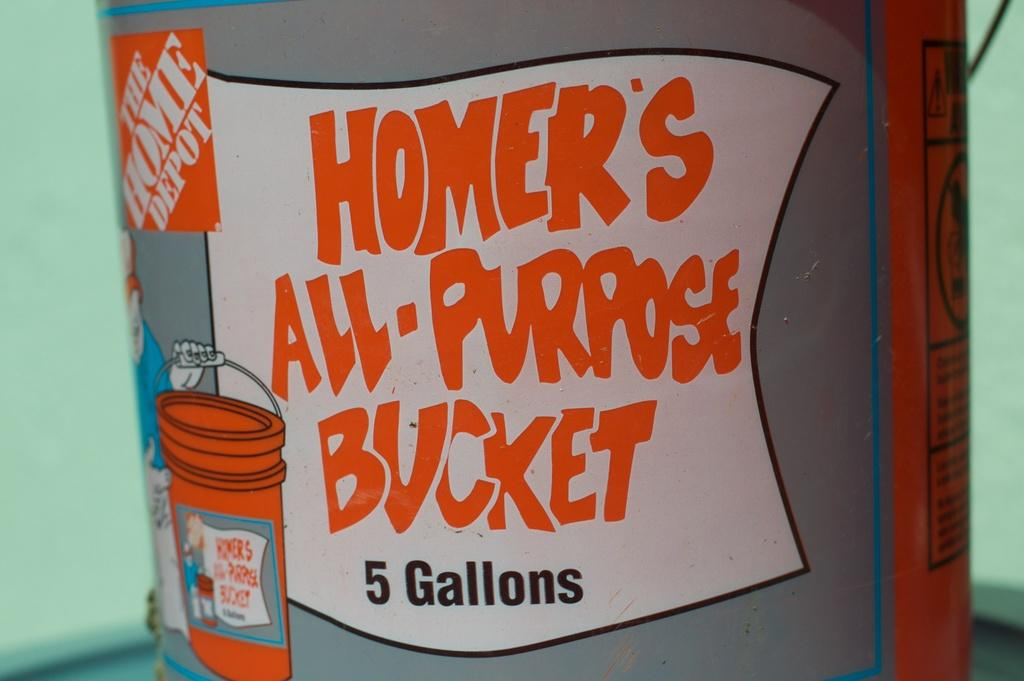<image>
Render a clear and concise summary of the photo. A bucket from Home Depot says it holds five gallons. 